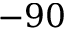Convert formula to latex. <formula><loc_0><loc_0><loc_500><loc_500>- 9 0</formula> 